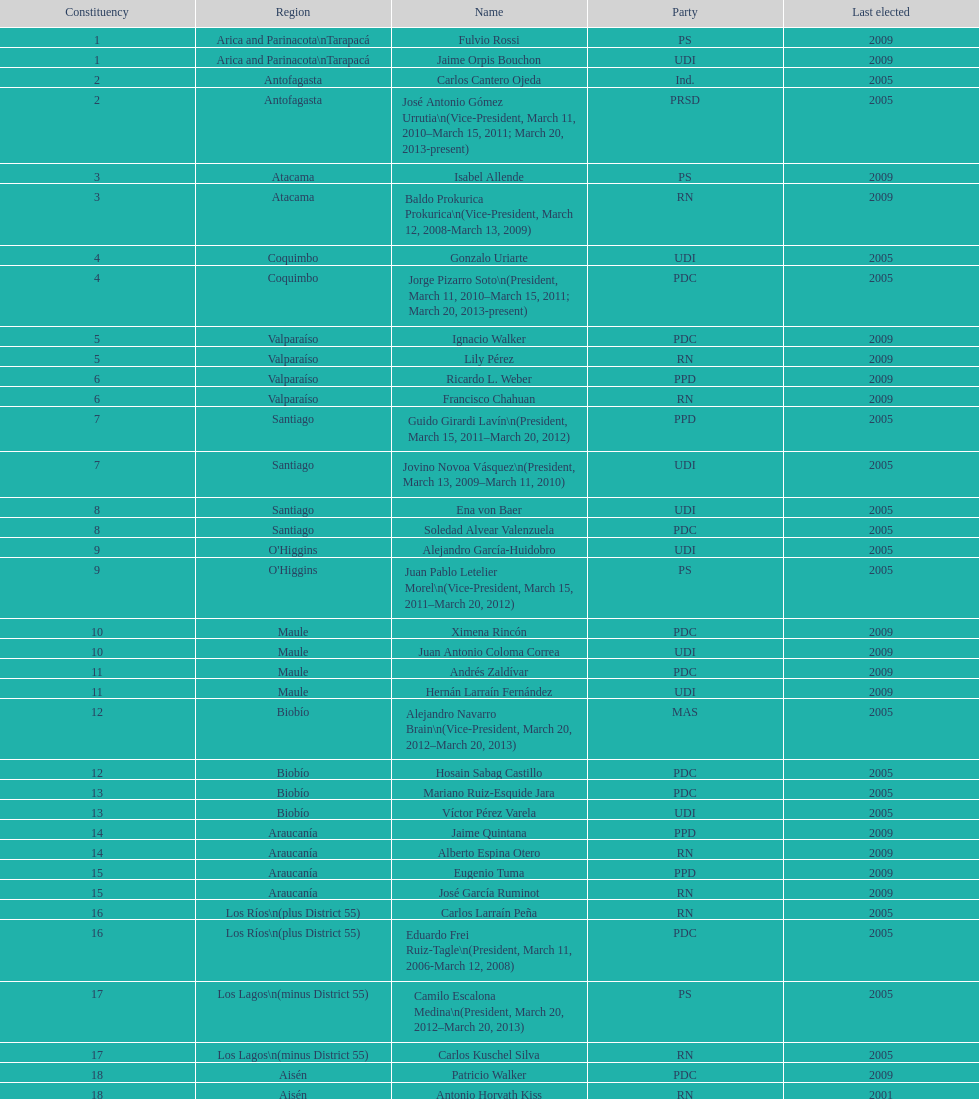Could you parse the entire table? {'header': ['Constituency', 'Region', 'Name', 'Party', 'Last elected'], 'rows': [['1', 'Arica and Parinacota\\nTarapacá', 'Fulvio Rossi', 'PS', '2009'], ['1', 'Arica and Parinacota\\nTarapacá', 'Jaime Orpis Bouchon', 'UDI', '2009'], ['2', 'Antofagasta', 'Carlos Cantero Ojeda', 'Ind.', '2005'], ['2', 'Antofagasta', 'José Antonio Gómez Urrutia\\n(Vice-President, March 11, 2010–March 15, 2011; March 20, 2013-present)', 'PRSD', '2005'], ['3', 'Atacama', 'Isabel Allende', 'PS', '2009'], ['3', 'Atacama', 'Baldo Prokurica Prokurica\\n(Vice-President, March 12, 2008-March 13, 2009)', 'RN', '2009'], ['4', 'Coquimbo', 'Gonzalo Uriarte', 'UDI', '2005'], ['4', 'Coquimbo', 'Jorge Pizarro Soto\\n(President, March 11, 2010–March 15, 2011; March 20, 2013-present)', 'PDC', '2005'], ['5', 'Valparaíso', 'Ignacio Walker', 'PDC', '2009'], ['5', 'Valparaíso', 'Lily Pérez', 'RN', '2009'], ['6', 'Valparaíso', 'Ricardo L. Weber', 'PPD', '2009'], ['6', 'Valparaíso', 'Francisco Chahuan', 'RN', '2009'], ['7', 'Santiago', 'Guido Girardi Lavín\\n(President, March 15, 2011–March 20, 2012)', 'PPD', '2005'], ['7', 'Santiago', 'Jovino Novoa Vásquez\\n(President, March 13, 2009–March 11, 2010)', 'UDI', '2005'], ['8', 'Santiago', 'Ena von Baer', 'UDI', '2005'], ['8', 'Santiago', 'Soledad Alvear Valenzuela', 'PDC', '2005'], ['9', "O'Higgins", 'Alejandro García-Huidobro', 'UDI', '2005'], ['9', "O'Higgins", 'Juan Pablo Letelier Morel\\n(Vice-President, March 15, 2011–March 20, 2012)', 'PS', '2005'], ['10', 'Maule', 'Ximena Rincón', 'PDC', '2009'], ['10', 'Maule', 'Juan Antonio Coloma Correa', 'UDI', '2009'], ['11', 'Maule', 'Andrés Zaldívar', 'PDC', '2009'], ['11', 'Maule', 'Hernán Larraín Fernández', 'UDI', '2009'], ['12', 'Biobío', 'Alejandro Navarro Brain\\n(Vice-President, March 20, 2012–March 20, 2013)', 'MAS', '2005'], ['12', 'Biobío', 'Hosain Sabag Castillo', 'PDC', '2005'], ['13', 'Biobío', 'Mariano Ruiz-Esquide Jara', 'PDC', '2005'], ['13', 'Biobío', 'Víctor Pérez Varela', 'UDI', '2005'], ['14', 'Araucanía', 'Jaime Quintana', 'PPD', '2009'], ['14', 'Araucanía', 'Alberto Espina Otero', 'RN', '2009'], ['15', 'Araucanía', 'Eugenio Tuma', 'PPD', '2009'], ['15', 'Araucanía', 'José García Ruminot', 'RN', '2009'], ['16', 'Los Ríos\\n(plus District 55)', 'Carlos Larraín Peña', 'RN', '2005'], ['16', 'Los Ríos\\n(plus District 55)', 'Eduardo Frei Ruiz-Tagle\\n(President, March 11, 2006-March 12, 2008)', 'PDC', '2005'], ['17', 'Los Lagos\\n(minus District 55)', 'Camilo Escalona Medina\\n(President, March 20, 2012–March 20, 2013)', 'PS', '2005'], ['17', 'Los Lagos\\n(minus District 55)', 'Carlos Kuschel Silva', 'RN', '2005'], ['18', 'Aisén', 'Patricio Walker', 'PDC', '2009'], ['18', 'Aisén', 'Antonio Horvath Kiss', 'RN', '2001'], ['19', 'Magallanes', 'Carlos Bianchi Chelech\\n(Vice-President, March 13, 2009–March 11, 2010)', 'Ind.', '2005'], ['19', 'Magallanes', 'Pedro Muñoz Aburto', 'PS', '2005']]} Which region is listed below atacama? Coquimbo. 